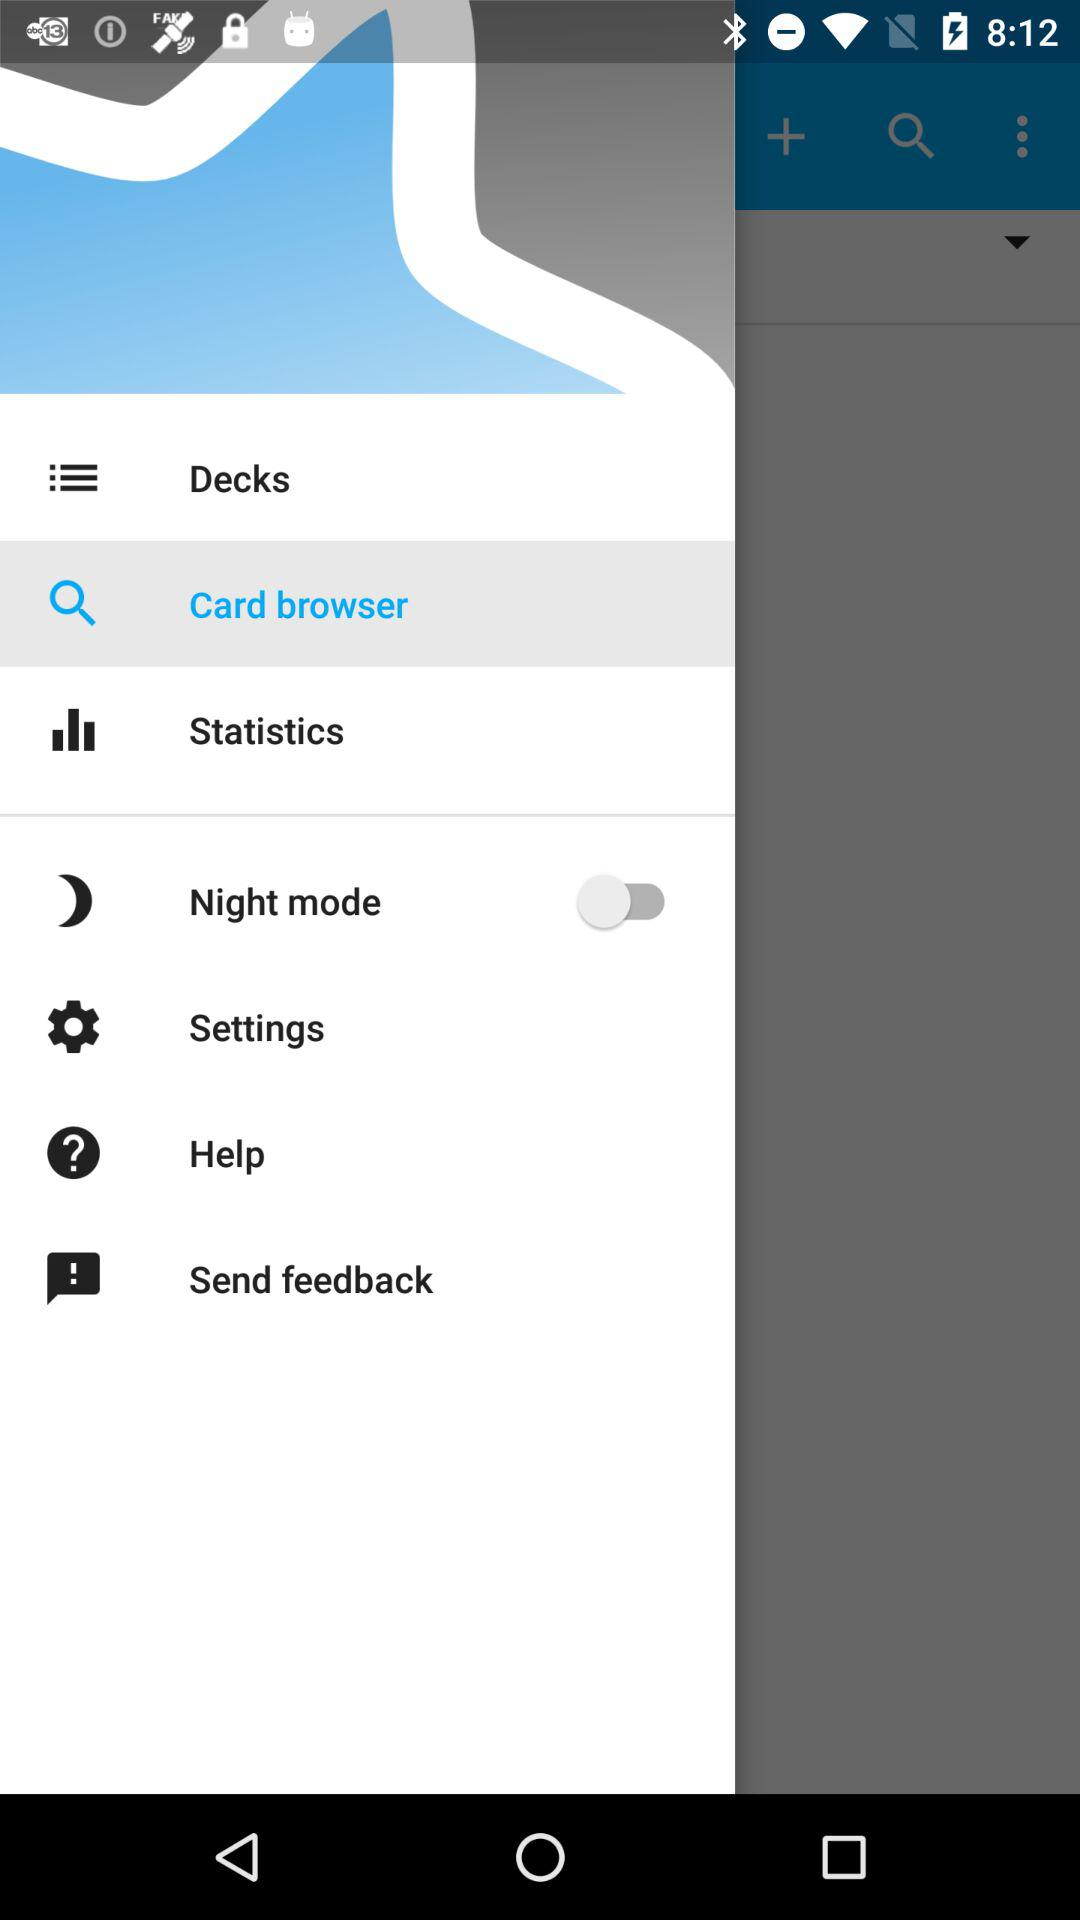What is the status of night mode? The status is off. 